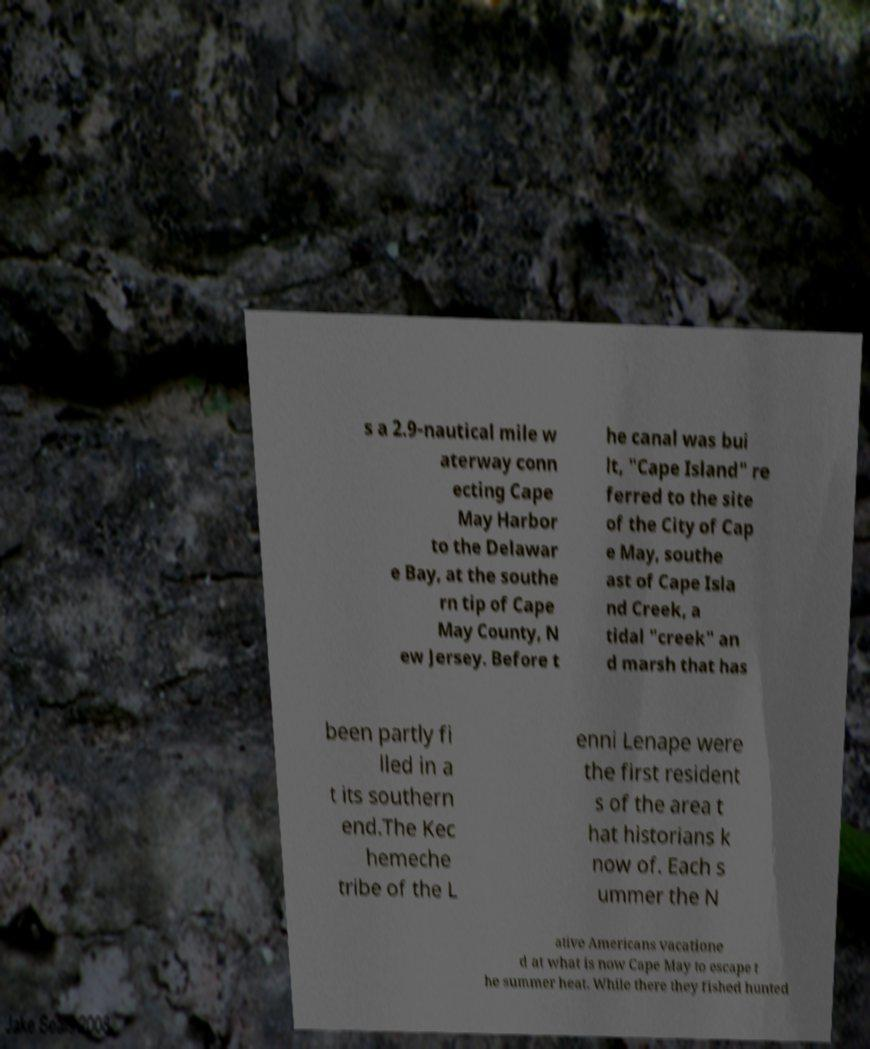Can you read and provide the text displayed in the image?This photo seems to have some interesting text. Can you extract and type it out for me? s a 2.9-nautical mile w aterway conn ecting Cape May Harbor to the Delawar e Bay, at the southe rn tip of Cape May County, N ew Jersey. Before t he canal was bui lt, "Cape Island" re ferred to the site of the City of Cap e May, southe ast of Cape Isla nd Creek, a tidal "creek" an d marsh that has been partly fi lled in a t its southern end.The Kec hemeche tribe of the L enni Lenape were the first resident s of the area t hat historians k now of. Each s ummer the N ative Americans vacatione d at what is now Cape May to escape t he summer heat. While there they fished hunted 